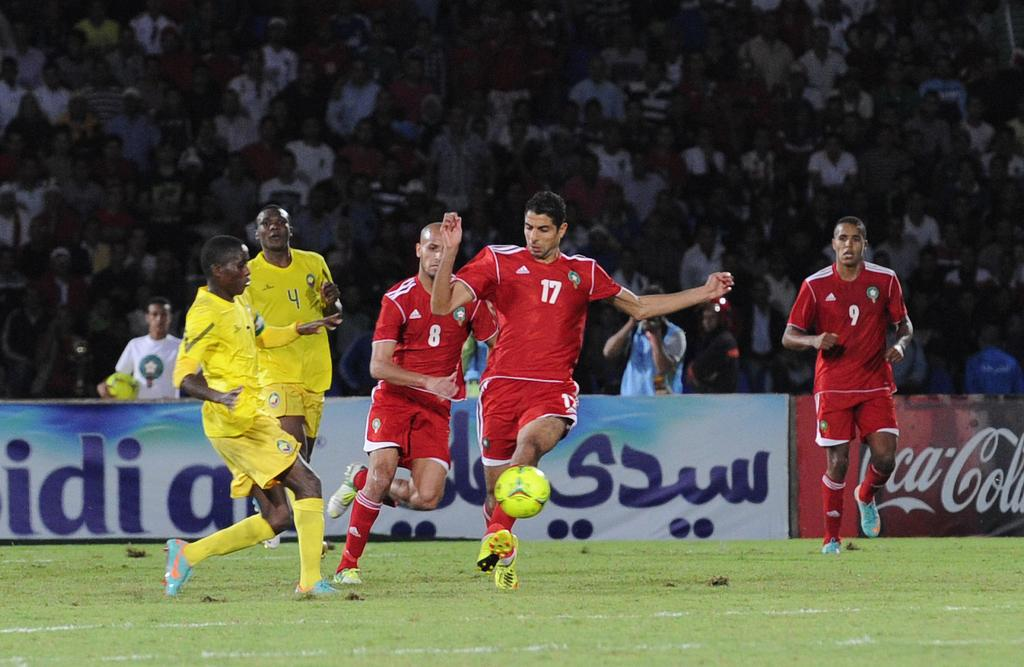<image>
Give a short and clear explanation of the subsequent image. Players race down the field near a sign for Coca Cola 